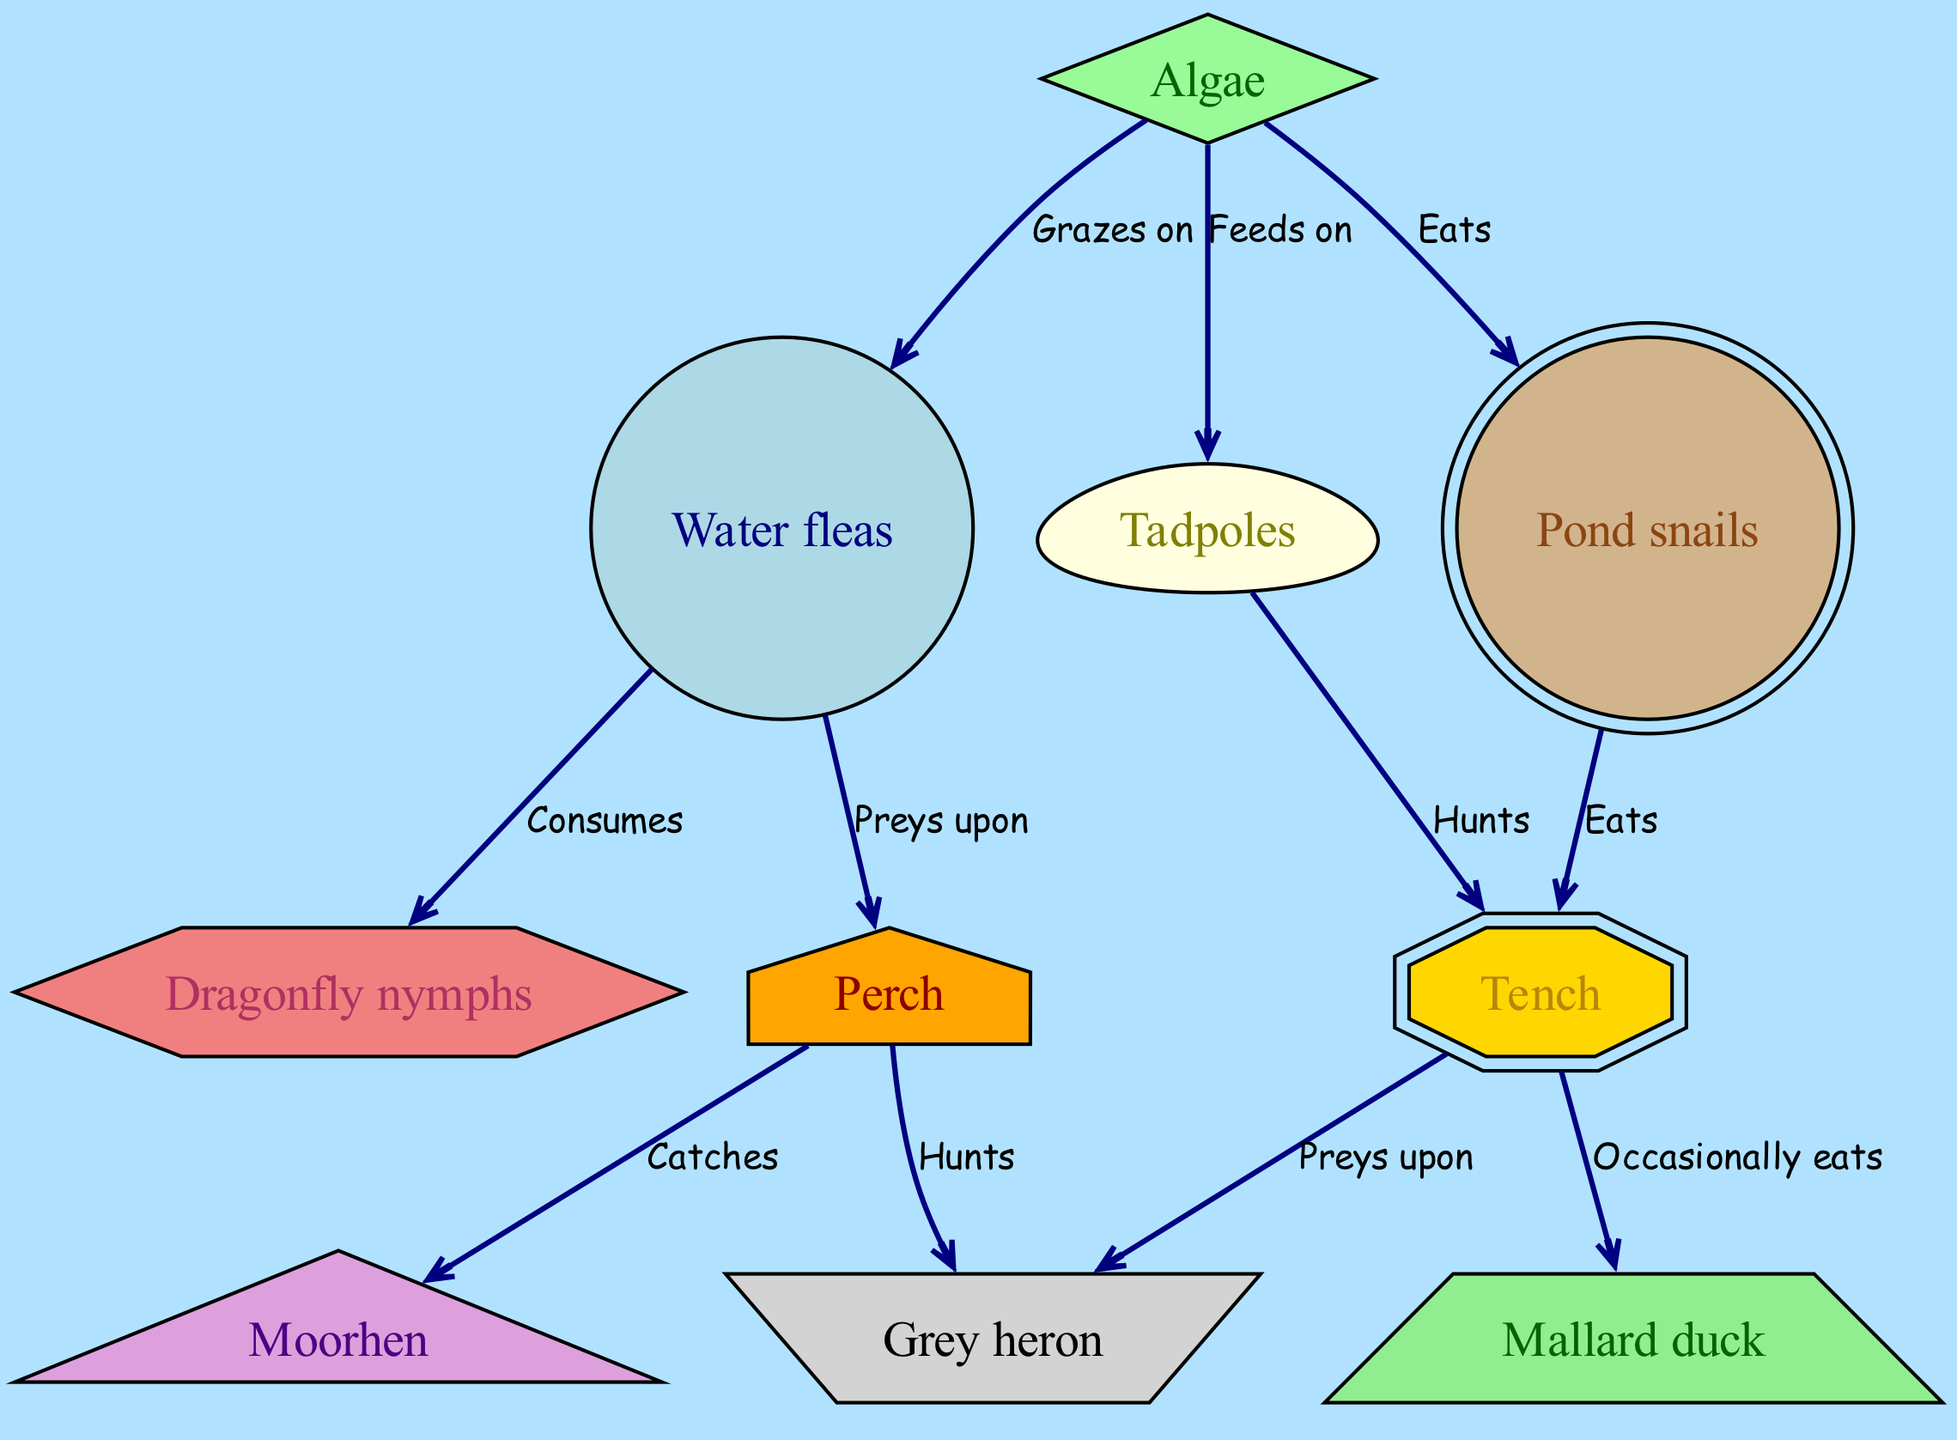How many nodes are in the diagram? The diagram specifies 10 unique nodes, which include various organisms from algae to herons. Counting each mentioned node results in a total of 10.
Answer: 10 What animal preys upon water fleas? The diagram indicates that perch preys upon water fleas, as represented by the directed edge labeled "Preys upon" from water fleas to perch.
Answer: Perch Which organism is at the top of the food chain? The diagram shows grey heron as the apex predator, receiving arrows from perch and tench that indicate it preys upon them, thus making it the top of the food chain in this ecosystem.
Answer: Grey heron What do tadpoles feed on? The diagram indicates that tadpoles feed on algae, demonstrated by the directed edge with the label "Feeds on" connecting algae to tadpoles.
Answer: Algae Which two organisms are preyed upon by the grey heron? The diagram shows two arrows directed from perch and tench to grey heron, indicating that grey heron preys upon both of these organisms. Therefore, they are the prey of grey heron.
Answer: Perch and Tench What is the relationship between dragonfly nymphs and water fleas? The diagram illustrates that water fleas consume dragonfly nymphs, as shown by the directed edge labeled "Consumes" that connects water fleas to dragonfly nymphs.
Answer: Consumes Which organism occasionally eats tench? According to the diagram, the mallard duck is indicated to occasionally eat tench, represented by the directed edge labeled "Occasionally eats" from tench to mallard duck.
Answer: Mallard duck How many organisms prey on tench? The diagram shows that two organisms, namely mallard duck and grey heron, prey on tench. Therefore, counting the arrows directed toward tench reveals two predators.
Answer: 2 Which organism is known to graze on algae? The diagram specifies that water fleas graze on algae, as indicated by the directed edge labeled "Grazes on" that connects algae to water fleas.
Answer: Water fleas 